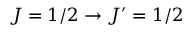Convert formula to latex. <formula><loc_0><loc_0><loc_500><loc_500>J = 1 / 2 \rightarrow J ^ { \prime } = 1 / 2</formula> 